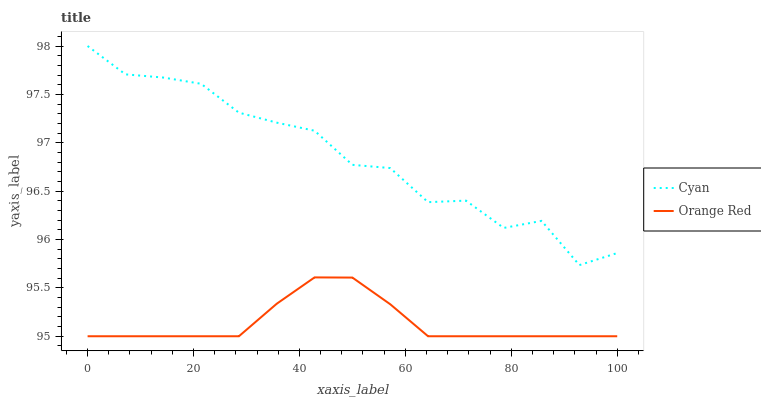Does Orange Red have the maximum area under the curve?
Answer yes or no. No. Is Orange Red the roughest?
Answer yes or no. No. Does Orange Red have the highest value?
Answer yes or no. No. Is Orange Red less than Cyan?
Answer yes or no. Yes. Is Cyan greater than Orange Red?
Answer yes or no. Yes. Does Orange Red intersect Cyan?
Answer yes or no. No. 